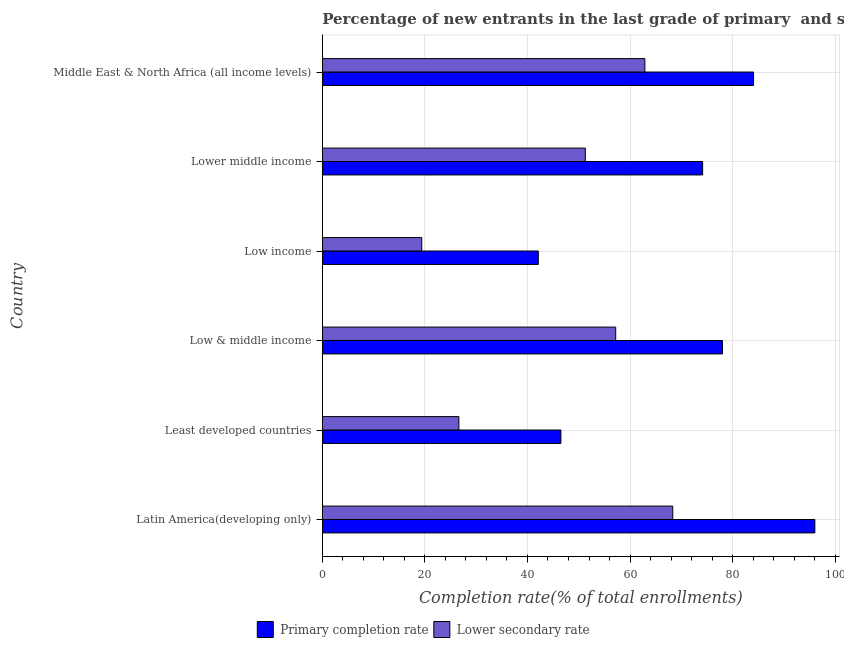Are the number of bars per tick equal to the number of legend labels?
Your answer should be very brief. Yes. How many bars are there on the 1st tick from the top?
Provide a succinct answer. 2. How many bars are there on the 4th tick from the bottom?
Keep it short and to the point. 2. What is the label of the 2nd group of bars from the top?
Ensure brevity in your answer.  Lower middle income. In how many cases, is the number of bars for a given country not equal to the number of legend labels?
Offer a very short reply. 0. What is the completion rate in primary schools in Low income?
Keep it short and to the point. 42.11. Across all countries, what is the maximum completion rate in primary schools?
Offer a terse response. 96.04. Across all countries, what is the minimum completion rate in primary schools?
Provide a short and direct response. 42.11. In which country was the completion rate in primary schools maximum?
Provide a succinct answer. Latin America(developing only). In which country was the completion rate in primary schools minimum?
Your answer should be very brief. Low income. What is the total completion rate in primary schools in the graph?
Ensure brevity in your answer.  420.93. What is the difference between the completion rate in primary schools in Low income and that in Lower middle income?
Your response must be concise. -32.04. What is the difference between the completion rate in secondary schools in Middle East & North Africa (all income levels) and the completion rate in primary schools in Low income?
Ensure brevity in your answer.  20.78. What is the average completion rate in primary schools per country?
Your answer should be compact. 70.16. What is the difference between the completion rate in secondary schools and completion rate in primary schools in Middle East & North Africa (all income levels)?
Your response must be concise. -21.19. In how many countries, is the completion rate in secondary schools greater than 84 %?
Ensure brevity in your answer.  0. What is the ratio of the completion rate in secondary schools in Latin America(developing only) to that in Least developed countries?
Give a very brief answer. 2.57. Is the difference between the completion rate in secondary schools in Low & middle income and Lower middle income greater than the difference between the completion rate in primary schools in Low & middle income and Lower middle income?
Offer a terse response. Yes. What is the difference between the highest and the second highest completion rate in primary schools?
Your answer should be compact. 11.95. What is the difference between the highest and the lowest completion rate in primary schools?
Ensure brevity in your answer.  53.92. In how many countries, is the completion rate in secondary schools greater than the average completion rate in secondary schools taken over all countries?
Give a very brief answer. 4. What does the 1st bar from the top in Low income represents?
Ensure brevity in your answer.  Lower secondary rate. What does the 2nd bar from the bottom in Low income represents?
Your response must be concise. Lower secondary rate. Are all the bars in the graph horizontal?
Your response must be concise. Yes. How many countries are there in the graph?
Give a very brief answer. 6. Where does the legend appear in the graph?
Offer a very short reply. Bottom center. How many legend labels are there?
Provide a succinct answer. 2. What is the title of the graph?
Offer a very short reply. Percentage of new entrants in the last grade of primary  and secondary schools in countries. Does "Domestic liabilities" appear as one of the legend labels in the graph?
Your response must be concise. No. What is the label or title of the X-axis?
Give a very brief answer. Completion rate(% of total enrollments). What is the Completion rate(% of total enrollments) of Primary completion rate in Latin America(developing only)?
Provide a succinct answer. 96.04. What is the Completion rate(% of total enrollments) in Lower secondary rate in Latin America(developing only)?
Give a very brief answer. 68.33. What is the Completion rate(% of total enrollments) of Primary completion rate in Least developed countries?
Your answer should be very brief. 46.52. What is the Completion rate(% of total enrollments) in Lower secondary rate in Least developed countries?
Give a very brief answer. 26.63. What is the Completion rate(% of total enrollments) in Primary completion rate in Low & middle income?
Offer a very short reply. 78.01. What is the Completion rate(% of total enrollments) of Lower secondary rate in Low & middle income?
Ensure brevity in your answer.  57.2. What is the Completion rate(% of total enrollments) of Primary completion rate in Low income?
Your answer should be compact. 42.11. What is the Completion rate(% of total enrollments) of Lower secondary rate in Low income?
Keep it short and to the point. 19.39. What is the Completion rate(% of total enrollments) of Primary completion rate in Lower middle income?
Offer a terse response. 74.16. What is the Completion rate(% of total enrollments) in Lower secondary rate in Lower middle income?
Make the answer very short. 51.28. What is the Completion rate(% of total enrollments) in Primary completion rate in Middle East & North Africa (all income levels)?
Your response must be concise. 84.08. What is the Completion rate(% of total enrollments) in Lower secondary rate in Middle East & North Africa (all income levels)?
Ensure brevity in your answer.  62.89. Across all countries, what is the maximum Completion rate(% of total enrollments) of Primary completion rate?
Ensure brevity in your answer.  96.04. Across all countries, what is the maximum Completion rate(% of total enrollments) of Lower secondary rate?
Give a very brief answer. 68.33. Across all countries, what is the minimum Completion rate(% of total enrollments) in Primary completion rate?
Give a very brief answer. 42.11. Across all countries, what is the minimum Completion rate(% of total enrollments) in Lower secondary rate?
Keep it short and to the point. 19.39. What is the total Completion rate(% of total enrollments) of Primary completion rate in the graph?
Offer a very short reply. 420.93. What is the total Completion rate(% of total enrollments) in Lower secondary rate in the graph?
Give a very brief answer. 285.72. What is the difference between the Completion rate(% of total enrollments) of Primary completion rate in Latin America(developing only) and that in Least developed countries?
Keep it short and to the point. 49.52. What is the difference between the Completion rate(% of total enrollments) of Lower secondary rate in Latin America(developing only) and that in Least developed countries?
Make the answer very short. 41.71. What is the difference between the Completion rate(% of total enrollments) of Primary completion rate in Latin America(developing only) and that in Low & middle income?
Make the answer very short. 18.03. What is the difference between the Completion rate(% of total enrollments) in Lower secondary rate in Latin America(developing only) and that in Low & middle income?
Give a very brief answer. 11.13. What is the difference between the Completion rate(% of total enrollments) of Primary completion rate in Latin America(developing only) and that in Low income?
Offer a terse response. 53.92. What is the difference between the Completion rate(% of total enrollments) of Lower secondary rate in Latin America(developing only) and that in Low income?
Offer a very short reply. 48.95. What is the difference between the Completion rate(% of total enrollments) of Primary completion rate in Latin America(developing only) and that in Lower middle income?
Your answer should be very brief. 21.88. What is the difference between the Completion rate(% of total enrollments) of Lower secondary rate in Latin America(developing only) and that in Lower middle income?
Offer a very short reply. 17.05. What is the difference between the Completion rate(% of total enrollments) in Primary completion rate in Latin America(developing only) and that in Middle East & North Africa (all income levels)?
Offer a terse response. 11.95. What is the difference between the Completion rate(% of total enrollments) of Lower secondary rate in Latin America(developing only) and that in Middle East & North Africa (all income levels)?
Your response must be concise. 5.44. What is the difference between the Completion rate(% of total enrollments) in Primary completion rate in Least developed countries and that in Low & middle income?
Make the answer very short. -31.49. What is the difference between the Completion rate(% of total enrollments) in Lower secondary rate in Least developed countries and that in Low & middle income?
Ensure brevity in your answer.  -30.58. What is the difference between the Completion rate(% of total enrollments) in Primary completion rate in Least developed countries and that in Low income?
Provide a short and direct response. 4.41. What is the difference between the Completion rate(% of total enrollments) in Lower secondary rate in Least developed countries and that in Low income?
Offer a very short reply. 7.24. What is the difference between the Completion rate(% of total enrollments) of Primary completion rate in Least developed countries and that in Lower middle income?
Provide a succinct answer. -27.64. What is the difference between the Completion rate(% of total enrollments) of Lower secondary rate in Least developed countries and that in Lower middle income?
Give a very brief answer. -24.65. What is the difference between the Completion rate(% of total enrollments) of Primary completion rate in Least developed countries and that in Middle East & North Africa (all income levels)?
Make the answer very short. -37.56. What is the difference between the Completion rate(% of total enrollments) in Lower secondary rate in Least developed countries and that in Middle East & North Africa (all income levels)?
Make the answer very short. -36.27. What is the difference between the Completion rate(% of total enrollments) of Primary completion rate in Low & middle income and that in Low income?
Provide a succinct answer. 35.9. What is the difference between the Completion rate(% of total enrollments) of Lower secondary rate in Low & middle income and that in Low income?
Provide a succinct answer. 37.82. What is the difference between the Completion rate(% of total enrollments) of Primary completion rate in Low & middle income and that in Lower middle income?
Make the answer very short. 3.86. What is the difference between the Completion rate(% of total enrollments) of Lower secondary rate in Low & middle income and that in Lower middle income?
Offer a very short reply. 5.92. What is the difference between the Completion rate(% of total enrollments) in Primary completion rate in Low & middle income and that in Middle East & North Africa (all income levels)?
Offer a very short reply. -6.07. What is the difference between the Completion rate(% of total enrollments) of Lower secondary rate in Low & middle income and that in Middle East & North Africa (all income levels)?
Offer a very short reply. -5.69. What is the difference between the Completion rate(% of total enrollments) of Primary completion rate in Low income and that in Lower middle income?
Give a very brief answer. -32.04. What is the difference between the Completion rate(% of total enrollments) of Lower secondary rate in Low income and that in Lower middle income?
Keep it short and to the point. -31.9. What is the difference between the Completion rate(% of total enrollments) in Primary completion rate in Low income and that in Middle East & North Africa (all income levels)?
Offer a very short reply. -41.97. What is the difference between the Completion rate(% of total enrollments) in Lower secondary rate in Low income and that in Middle East & North Africa (all income levels)?
Your response must be concise. -43.51. What is the difference between the Completion rate(% of total enrollments) in Primary completion rate in Lower middle income and that in Middle East & North Africa (all income levels)?
Keep it short and to the point. -9.93. What is the difference between the Completion rate(% of total enrollments) in Lower secondary rate in Lower middle income and that in Middle East & North Africa (all income levels)?
Provide a short and direct response. -11.61. What is the difference between the Completion rate(% of total enrollments) in Primary completion rate in Latin America(developing only) and the Completion rate(% of total enrollments) in Lower secondary rate in Least developed countries?
Your response must be concise. 69.41. What is the difference between the Completion rate(% of total enrollments) of Primary completion rate in Latin America(developing only) and the Completion rate(% of total enrollments) of Lower secondary rate in Low & middle income?
Offer a terse response. 38.83. What is the difference between the Completion rate(% of total enrollments) in Primary completion rate in Latin America(developing only) and the Completion rate(% of total enrollments) in Lower secondary rate in Low income?
Your answer should be very brief. 76.65. What is the difference between the Completion rate(% of total enrollments) of Primary completion rate in Latin America(developing only) and the Completion rate(% of total enrollments) of Lower secondary rate in Lower middle income?
Keep it short and to the point. 44.76. What is the difference between the Completion rate(% of total enrollments) in Primary completion rate in Latin America(developing only) and the Completion rate(% of total enrollments) in Lower secondary rate in Middle East & North Africa (all income levels)?
Offer a terse response. 33.15. What is the difference between the Completion rate(% of total enrollments) of Primary completion rate in Least developed countries and the Completion rate(% of total enrollments) of Lower secondary rate in Low & middle income?
Keep it short and to the point. -10.68. What is the difference between the Completion rate(% of total enrollments) of Primary completion rate in Least developed countries and the Completion rate(% of total enrollments) of Lower secondary rate in Low income?
Provide a succinct answer. 27.14. What is the difference between the Completion rate(% of total enrollments) of Primary completion rate in Least developed countries and the Completion rate(% of total enrollments) of Lower secondary rate in Lower middle income?
Keep it short and to the point. -4.76. What is the difference between the Completion rate(% of total enrollments) in Primary completion rate in Least developed countries and the Completion rate(% of total enrollments) in Lower secondary rate in Middle East & North Africa (all income levels)?
Keep it short and to the point. -16.37. What is the difference between the Completion rate(% of total enrollments) of Primary completion rate in Low & middle income and the Completion rate(% of total enrollments) of Lower secondary rate in Low income?
Your answer should be very brief. 58.63. What is the difference between the Completion rate(% of total enrollments) of Primary completion rate in Low & middle income and the Completion rate(% of total enrollments) of Lower secondary rate in Lower middle income?
Offer a terse response. 26.73. What is the difference between the Completion rate(% of total enrollments) in Primary completion rate in Low & middle income and the Completion rate(% of total enrollments) in Lower secondary rate in Middle East & North Africa (all income levels)?
Your response must be concise. 15.12. What is the difference between the Completion rate(% of total enrollments) in Primary completion rate in Low income and the Completion rate(% of total enrollments) in Lower secondary rate in Lower middle income?
Keep it short and to the point. -9.17. What is the difference between the Completion rate(% of total enrollments) in Primary completion rate in Low income and the Completion rate(% of total enrollments) in Lower secondary rate in Middle East & North Africa (all income levels)?
Your answer should be compact. -20.78. What is the difference between the Completion rate(% of total enrollments) of Primary completion rate in Lower middle income and the Completion rate(% of total enrollments) of Lower secondary rate in Middle East & North Africa (all income levels)?
Provide a short and direct response. 11.26. What is the average Completion rate(% of total enrollments) in Primary completion rate per country?
Your answer should be compact. 70.15. What is the average Completion rate(% of total enrollments) of Lower secondary rate per country?
Provide a succinct answer. 47.62. What is the difference between the Completion rate(% of total enrollments) in Primary completion rate and Completion rate(% of total enrollments) in Lower secondary rate in Latin America(developing only)?
Give a very brief answer. 27.71. What is the difference between the Completion rate(% of total enrollments) of Primary completion rate and Completion rate(% of total enrollments) of Lower secondary rate in Least developed countries?
Offer a terse response. 19.89. What is the difference between the Completion rate(% of total enrollments) in Primary completion rate and Completion rate(% of total enrollments) in Lower secondary rate in Low & middle income?
Provide a succinct answer. 20.81. What is the difference between the Completion rate(% of total enrollments) in Primary completion rate and Completion rate(% of total enrollments) in Lower secondary rate in Low income?
Your response must be concise. 22.73. What is the difference between the Completion rate(% of total enrollments) of Primary completion rate and Completion rate(% of total enrollments) of Lower secondary rate in Lower middle income?
Offer a very short reply. 22.88. What is the difference between the Completion rate(% of total enrollments) of Primary completion rate and Completion rate(% of total enrollments) of Lower secondary rate in Middle East & North Africa (all income levels)?
Your answer should be very brief. 21.19. What is the ratio of the Completion rate(% of total enrollments) in Primary completion rate in Latin America(developing only) to that in Least developed countries?
Provide a short and direct response. 2.06. What is the ratio of the Completion rate(% of total enrollments) in Lower secondary rate in Latin America(developing only) to that in Least developed countries?
Provide a succinct answer. 2.57. What is the ratio of the Completion rate(% of total enrollments) of Primary completion rate in Latin America(developing only) to that in Low & middle income?
Your answer should be very brief. 1.23. What is the ratio of the Completion rate(% of total enrollments) of Lower secondary rate in Latin America(developing only) to that in Low & middle income?
Provide a short and direct response. 1.19. What is the ratio of the Completion rate(% of total enrollments) of Primary completion rate in Latin America(developing only) to that in Low income?
Offer a very short reply. 2.28. What is the ratio of the Completion rate(% of total enrollments) of Lower secondary rate in Latin America(developing only) to that in Low income?
Give a very brief answer. 3.52. What is the ratio of the Completion rate(% of total enrollments) of Primary completion rate in Latin America(developing only) to that in Lower middle income?
Give a very brief answer. 1.3. What is the ratio of the Completion rate(% of total enrollments) in Lower secondary rate in Latin America(developing only) to that in Lower middle income?
Your response must be concise. 1.33. What is the ratio of the Completion rate(% of total enrollments) of Primary completion rate in Latin America(developing only) to that in Middle East & North Africa (all income levels)?
Your answer should be very brief. 1.14. What is the ratio of the Completion rate(% of total enrollments) of Lower secondary rate in Latin America(developing only) to that in Middle East & North Africa (all income levels)?
Make the answer very short. 1.09. What is the ratio of the Completion rate(% of total enrollments) of Primary completion rate in Least developed countries to that in Low & middle income?
Your answer should be very brief. 0.6. What is the ratio of the Completion rate(% of total enrollments) in Lower secondary rate in Least developed countries to that in Low & middle income?
Offer a very short reply. 0.47. What is the ratio of the Completion rate(% of total enrollments) of Primary completion rate in Least developed countries to that in Low income?
Your answer should be very brief. 1.1. What is the ratio of the Completion rate(% of total enrollments) in Lower secondary rate in Least developed countries to that in Low income?
Provide a succinct answer. 1.37. What is the ratio of the Completion rate(% of total enrollments) of Primary completion rate in Least developed countries to that in Lower middle income?
Your answer should be very brief. 0.63. What is the ratio of the Completion rate(% of total enrollments) of Lower secondary rate in Least developed countries to that in Lower middle income?
Your answer should be very brief. 0.52. What is the ratio of the Completion rate(% of total enrollments) of Primary completion rate in Least developed countries to that in Middle East & North Africa (all income levels)?
Your answer should be very brief. 0.55. What is the ratio of the Completion rate(% of total enrollments) in Lower secondary rate in Least developed countries to that in Middle East & North Africa (all income levels)?
Keep it short and to the point. 0.42. What is the ratio of the Completion rate(% of total enrollments) of Primary completion rate in Low & middle income to that in Low income?
Your answer should be compact. 1.85. What is the ratio of the Completion rate(% of total enrollments) in Lower secondary rate in Low & middle income to that in Low income?
Your response must be concise. 2.95. What is the ratio of the Completion rate(% of total enrollments) of Primary completion rate in Low & middle income to that in Lower middle income?
Give a very brief answer. 1.05. What is the ratio of the Completion rate(% of total enrollments) of Lower secondary rate in Low & middle income to that in Lower middle income?
Provide a succinct answer. 1.12. What is the ratio of the Completion rate(% of total enrollments) in Primary completion rate in Low & middle income to that in Middle East & North Africa (all income levels)?
Provide a short and direct response. 0.93. What is the ratio of the Completion rate(% of total enrollments) of Lower secondary rate in Low & middle income to that in Middle East & North Africa (all income levels)?
Offer a terse response. 0.91. What is the ratio of the Completion rate(% of total enrollments) of Primary completion rate in Low income to that in Lower middle income?
Provide a short and direct response. 0.57. What is the ratio of the Completion rate(% of total enrollments) in Lower secondary rate in Low income to that in Lower middle income?
Ensure brevity in your answer.  0.38. What is the ratio of the Completion rate(% of total enrollments) in Primary completion rate in Low income to that in Middle East & North Africa (all income levels)?
Your response must be concise. 0.5. What is the ratio of the Completion rate(% of total enrollments) in Lower secondary rate in Low income to that in Middle East & North Africa (all income levels)?
Ensure brevity in your answer.  0.31. What is the ratio of the Completion rate(% of total enrollments) in Primary completion rate in Lower middle income to that in Middle East & North Africa (all income levels)?
Offer a terse response. 0.88. What is the ratio of the Completion rate(% of total enrollments) of Lower secondary rate in Lower middle income to that in Middle East & North Africa (all income levels)?
Make the answer very short. 0.82. What is the difference between the highest and the second highest Completion rate(% of total enrollments) of Primary completion rate?
Your answer should be compact. 11.95. What is the difference between the highest and the second highest Completion rate(% of total enrollments) of Lower secondary rate?
Your response must be concise. 5.44. What is the difference between the highest and the lowest Completion rate(% of total enrollments) in Primary completion rate?
Your answer should be compact. 53.92. What is the difference between the highest and the lowest Completion rate(% of total enrollments) in Lower secondary rate?
Provide a succinct answer. 48.95. 